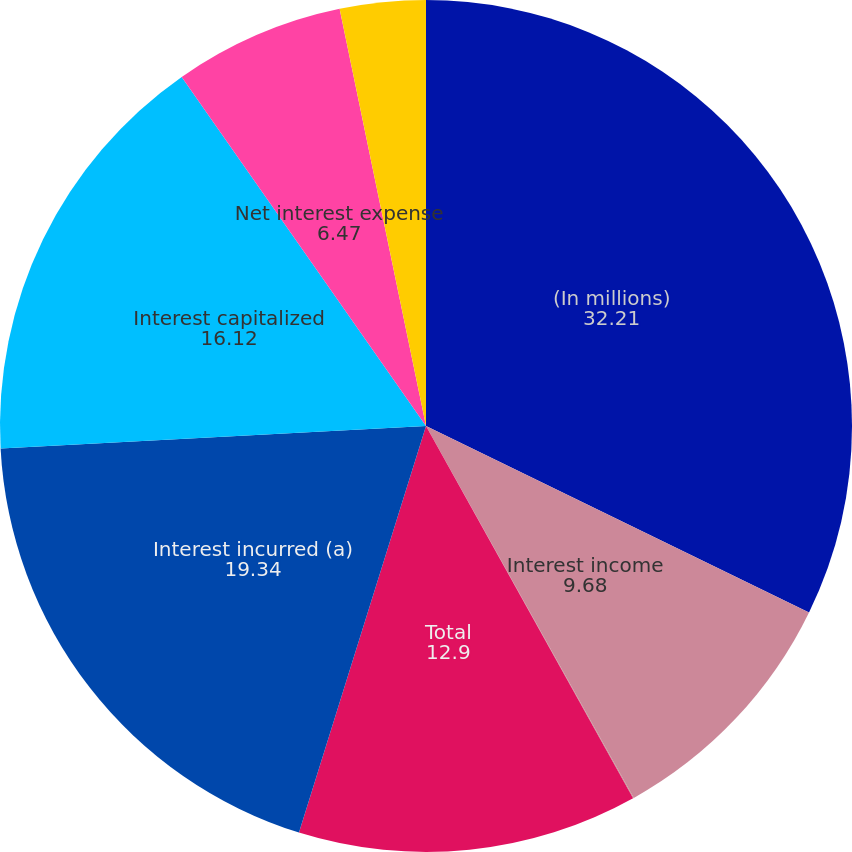Convert chart to OTSL. <chart><loc_0><loc_0><loc_500><loc_500><pie_chart><fcel>(In millions)<fcel>Interest income<fcel>Foreign currency gains<fcel>Total<fcel>Interest incurred (a)<fcel>Interest capitalized<fcel>Net interest expense<fcel>Other<nl><fcel>32.21%<fcel>9.68%<fcel>0.03%<fcel>12.9%<fcel>19.34%<fcel>16.12%<fcel>6.47%<fcel>3.25%<nl></chart> 